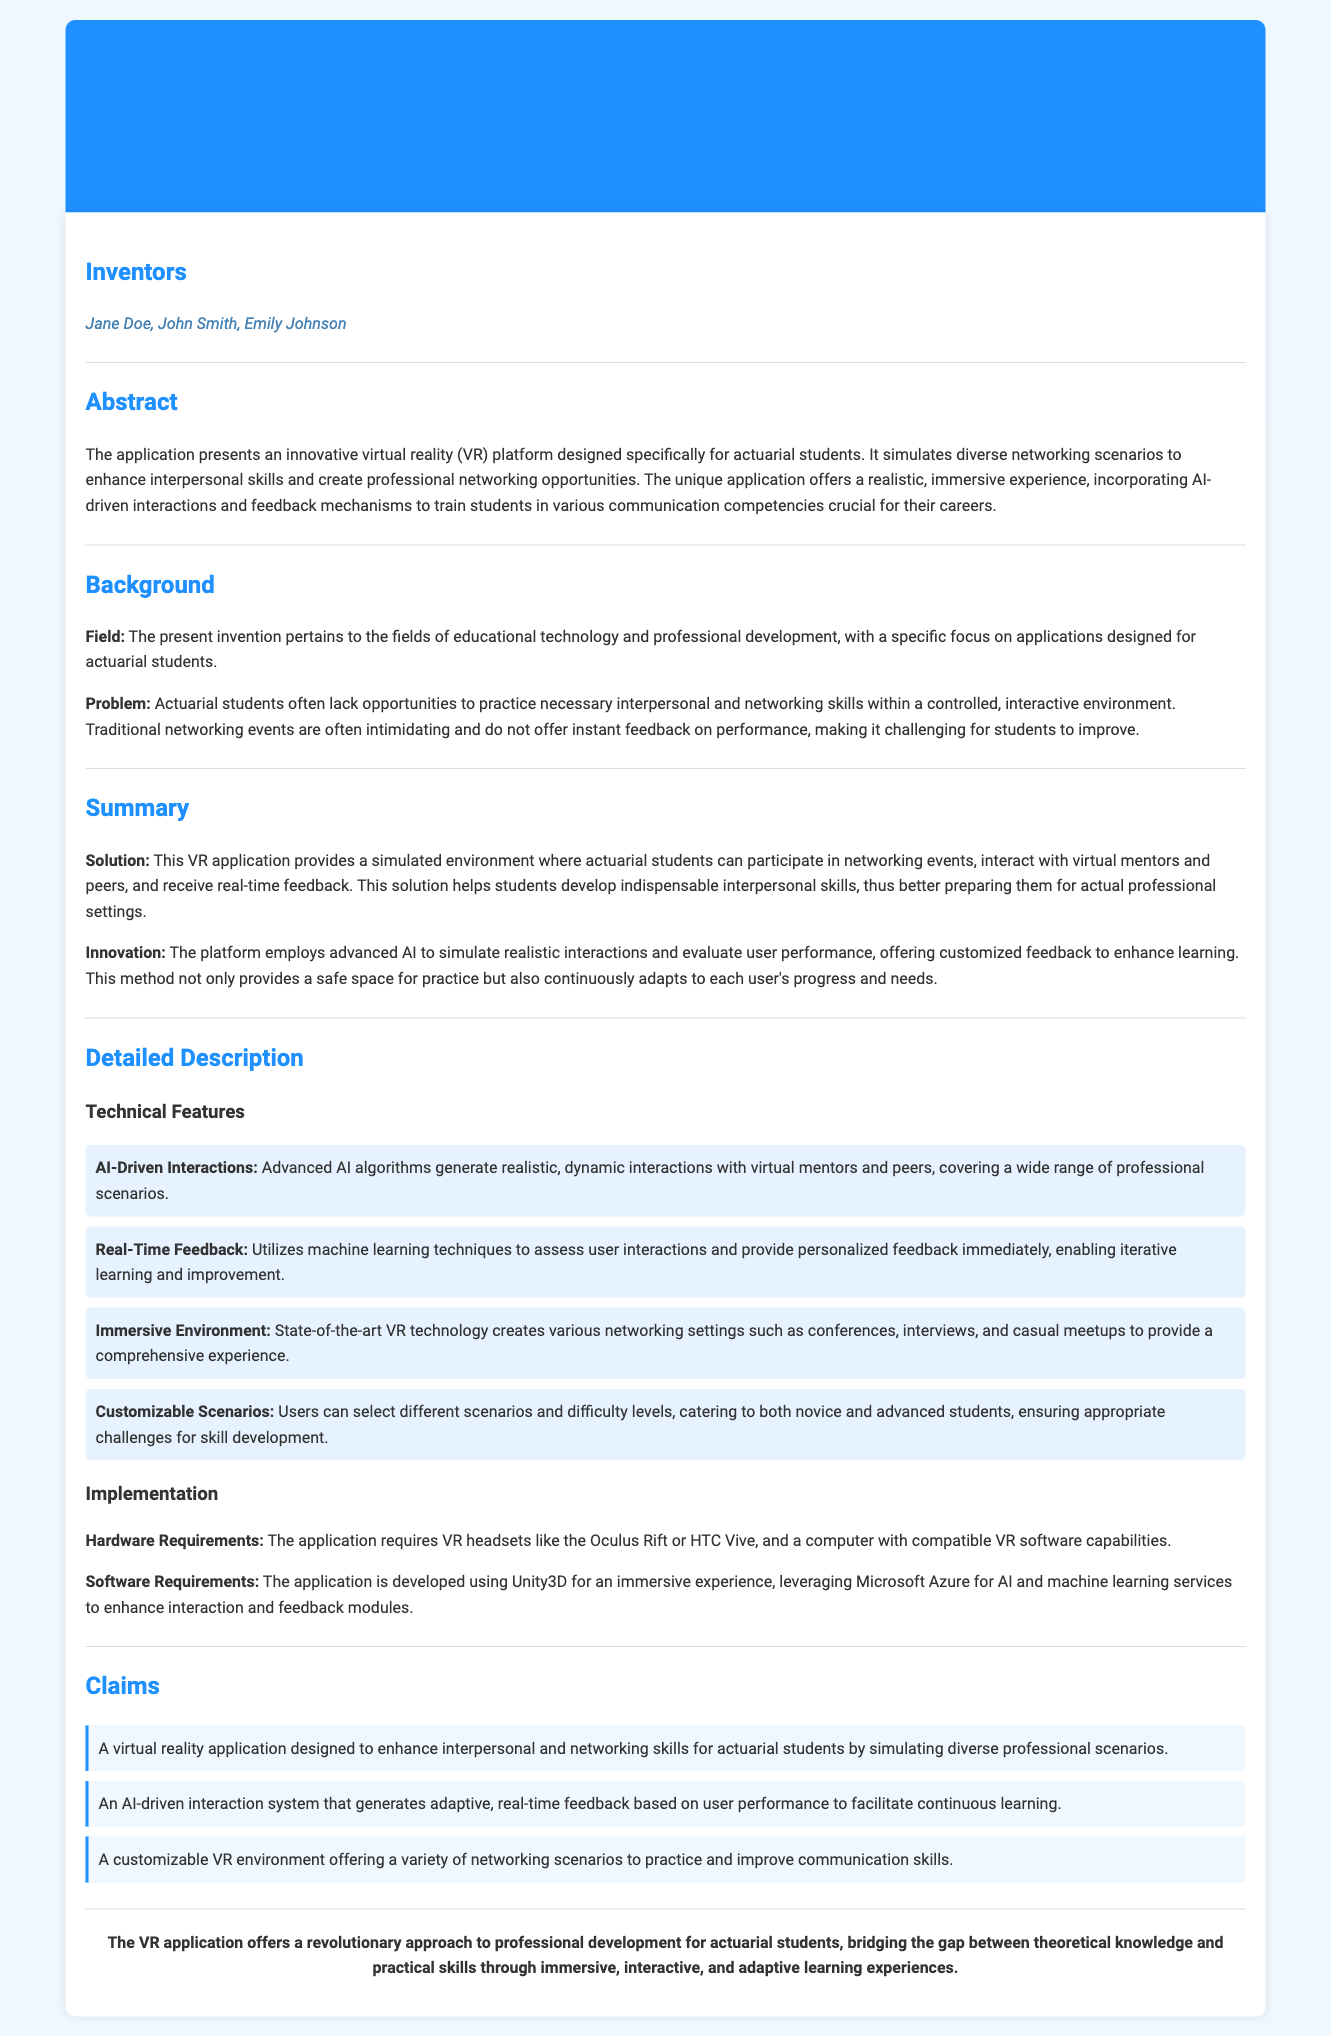what is the title of the patent application? The title clearly states the subject of the application, which is focused on a specific VR platform created for actuarial students.
Answer: A Virtual Reality Application for Simulated Networking Events who are the inventors? The inventors' names are listed under the corresponding section in the document, which details the individuals involved in the creation of the application.
Answer: Jane Doe, John Smith, Emily Johnson what problem does the invention address? The problem is outlined in the background section, explaining the challenges faced by actuarial students in developing networking skills.
Answer: Lack of opportunities to practice necessary interpersonal and networking skills how does the application enhance learning? The solution highlights how the application provides a simulated environment and real-time feedback, facilitating better learning experiences.
Answer: Real-time feedback what technology is used for development? The detailed description specifies the technology employed in development, which aids in providing immersive experiences.
Answer: Unity3D how many claims are mentioned in the patent application? The claims section enumerates the specific claims made regarding the technology, indicating the number of claims made.
Answer: Three what type of environments can users practice in? The detailed description elaborates on various networking scenarios that users can engage with during simulations.
Answer: Conferences, interviews, casual meetups what is the primary focus of the invention? The abstract points out that the application is focused specifically on enhancing interpersonal skills and networking opportunities for actuarial students.
Answer: Interpersonal skills and professional networking opportunities 